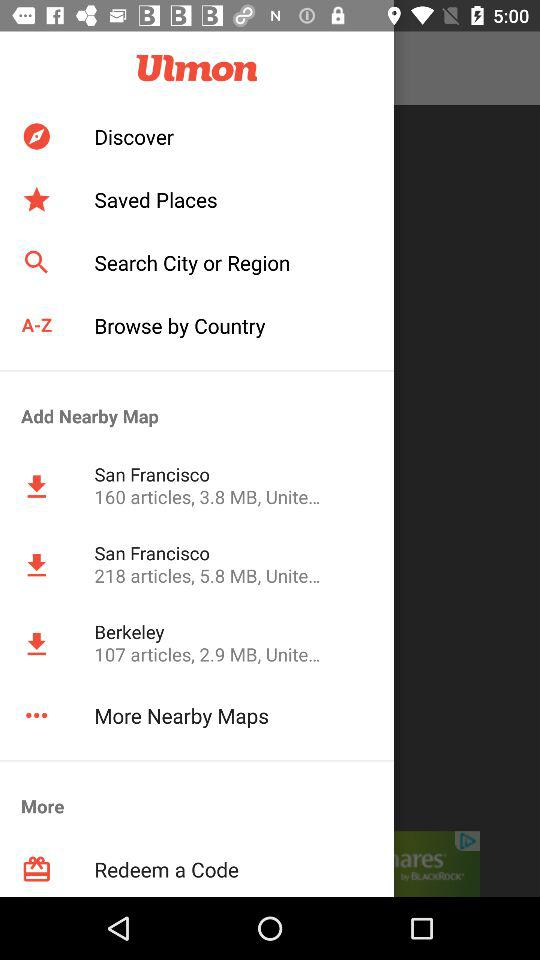What is the name of the application? The name of the application is "Ulmon". 